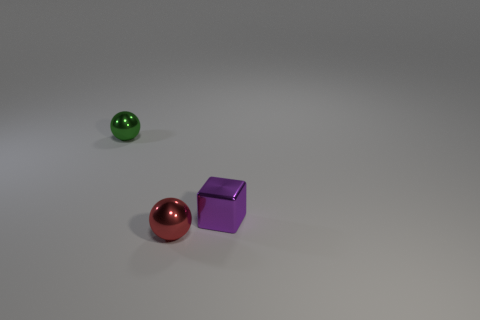The tiny metal thing that is on the left side of the purple shiny thing and behind the tiny red object has what shape?
Offer a very short reply. Sphere. The sphere that is the same size as the red thing is what color?
Offer a very short reply. Green. Are there any other small metal cubes of the same color as the small cube?
Provide a succinct answer. No. There is a tiny thing that is both right of the green metallic ball and behind the tiny red shiny thing; what material is it?
Give a very brief answer. Metal. What number of other objects are the same size as the purple metallic object?
Ensure brevity in your answer.  2. What is the material of the tiny object behind the block?
Ensure brevity in your answer.  Metal. Is the green metallic thing the same shape as the small red shiny object?
Offer a very short reply. Yes. What number of other things are there of the same shape as the small green thing?
Provide a succinct answer. 1. There is a object that is in front of the purple block; what is its color?
Offer a terse response. Red. What material is the tiny ball in front of the metallic ball on the left side of the tiny red sphere?
Provide a short and direct response. Metal. 